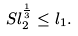<formula> <loc_0><loc_0><loc_500><loc_500>S l _ { 2 } ^ { \frac { 1 } { 3 } } \leq l _ { 1 } .</formula> 